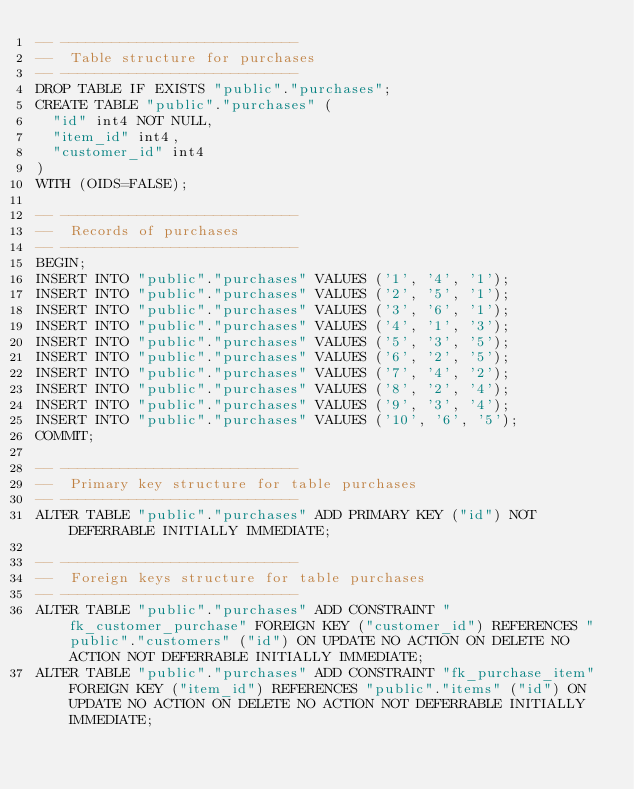Convert code to text. <code><loc_0><loc_0><loc_500><loc_500><_SQL_>-- ----------------------------
--  Table structure for purchases
-- ----------------------------
DROP TABLE IF EXISTS "public"."purchases";
CREATE TABLE "public"."purchases" (
	"id" int4 NOT NULL,
	"item_id" int4,
	"customer_id" int4
)
WITH (OIDS=FALSE);

-- ----------------------------
--  Records of purchases
-- ----------------------------
BEGIN;
INSERT INTO "public"."purchases" VALUES ('1', '4', '1');
INSERT INTO "public"."purchases" VALUES ('2', '5', '1');
INSERT INTO "public"."purchases" VALUES ('3', '6', '1');
INSERT INTO "public"."purchases" VALUES ('4', '1', '3');
INSERT INTO "public"."purchases" VALUES ('5', '3', '5');
INSERT INTO "public"."purchases" VALUES ('6', '2', '5');
INSERT INTO "public"."purchases" VALUES ('7', '4', '2');
INSERT INTO "public"."purchases" VALUES ('8', '2', '4');
INSERT INTO "public"."purchases" VALUES ('9', '3', '4');
INSERT INTO "public"."purchases" VALUES ('10', '6', '5');
COMMIT;

-- ----------------------------
--  Primary key structure for table purchases
-- ----------------------------
ALTER TABLE "public"."purchases" ADD PRIMARY KEY ("id") NOT DEFERRABLE INITIALLY IMMEDIATE;

-- ----------------------------
--  Foreign keys structure for table purchases
-- ----------------------------
ALTER TABLE "public"."purchases" ADD CONSTRAINT "fk_customer_purchase" FOREIGN KEY ("customer_id") REFERENCES "public"."customers" ("id") ON UPDATE NO ACTION ON DELETE NO ACTION NOT DEFERRABLE INITIALLY IMMEDIATE;
ALTER TABLE "public"."purchases" ADD CONSTRAINT "fk_purchase_item" FOREIGN KEY ("item_id") REFERENCES "public"."items" ("id") ON UPDATE NO ACTION ON DELETE NO ACTION NOT DEFERRABLE INITIALLY IMMEDIATE;
</code> 